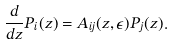<formula> <loc_0><loc_0><loc_500><loc_500>\frac { d } { d z } P _ { i } ( z ) = A _ { i j } ( z , \epsilon ) P _ { j } ( z ) .</formula> 